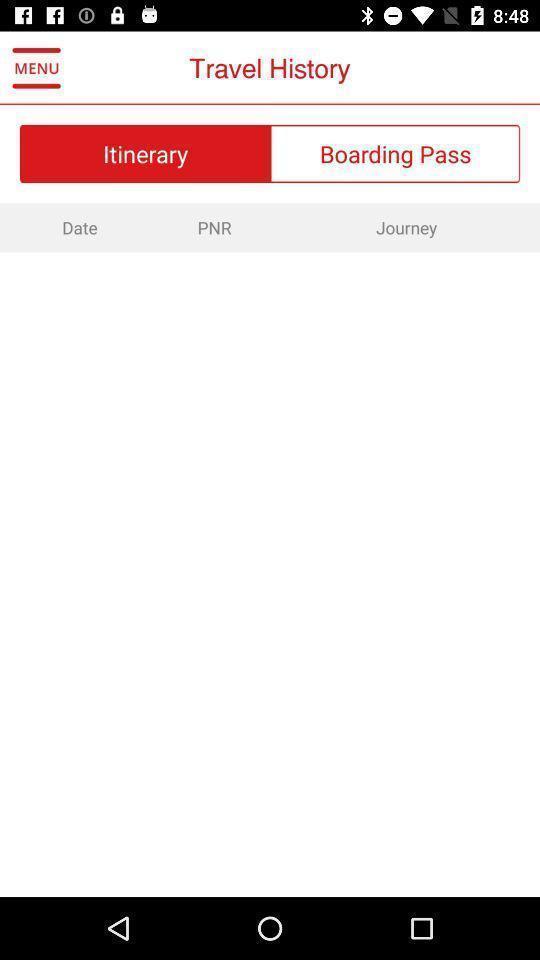Explain what's happening in this screen capture. Page that displaying airlines application. 